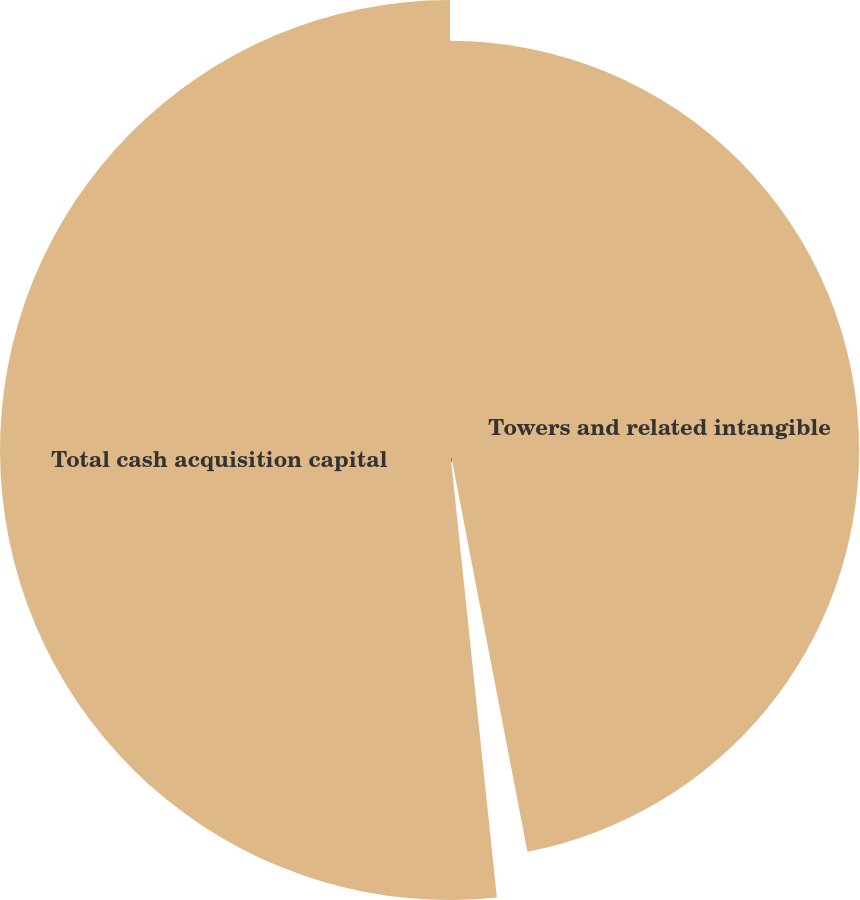<chart> <loc_0><loc_0><loc_500><loc_500><pie_chart><fcel>Towers and related intangible<fcel>Land buyouts (2)<fcel>Total cash acquisition capital<nl><fcel>46.97%<fcel>1.37%<fcel>51.66%<nl></chart> 